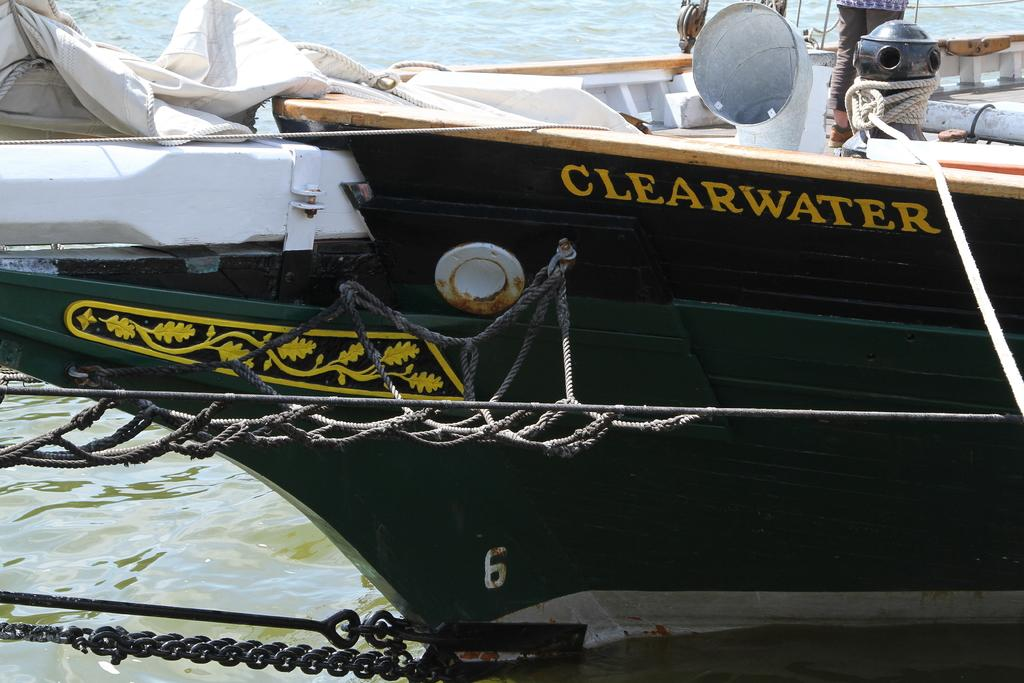What is the main subject in the center of the image? There is a green color boat in the center of the image. What is visible at the bottom of the image? There is water visible at the bottom of the image. What object can be seen on the left side of the image? There is a chain on the left side of the image. How much money is being exchanged in the image? There is no indication of money or any exchange in the image; it features a green color boat, water, and a chain. Can you tell me how many people are joining the boat in the image? There is no indication of people or any activity involving joining the boat in the image. 